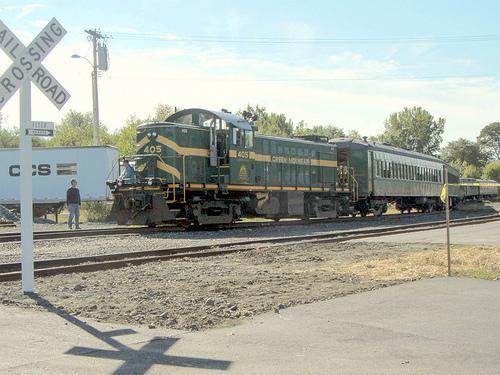How many people are in this picture?
Give a very brief answer. 1. How many cars are on the train?
Give a very brief answer. 2. 